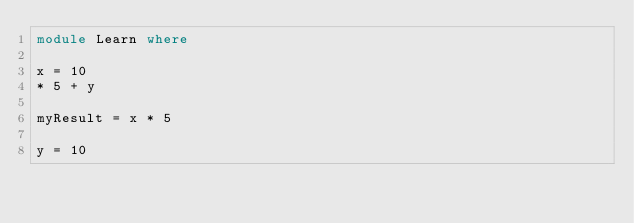<code> <loc_0><loc_0><loc_500><loc_500><_Haskell_>module Learn where

x = 10
* 5 + y

myResult = x * 5

y = 10
</code> 